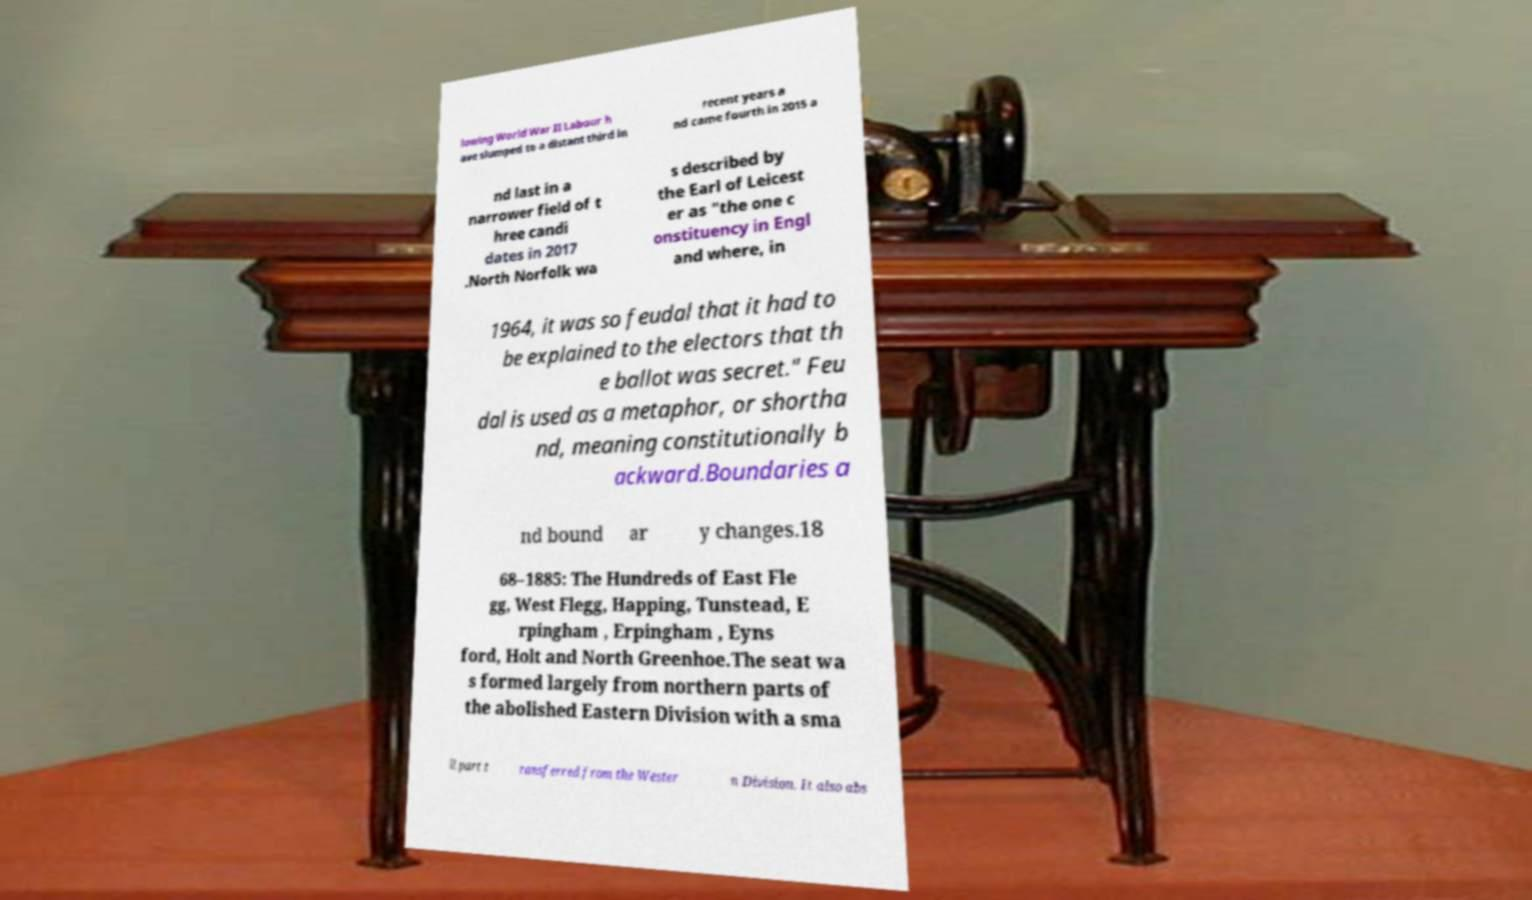Can you accurately transcribe the text from the provided image for me? lowing World War II Labour h ave slumped to a distant third in recent years a nd came fourth in 2015 a nd last in a narrower field of t hree candi dates in 2017 .North Norfolk wa s described by the Earl of Leicest er as "the one c onstituency in Engl and where, in 1964, it was so feudal that it had to be explained to the electors that th e ballot was secret." Feu dal is used as a metaphor, or shortha nd, meaning constitutionally b ackward.Boundaries a nd bound ar y changes.18 68–1885: The Hundreds of East Fle gg, West Flegg, Happing, Tunstead, E rpingham , Erpingham , Eyns ford, Holt and North Greenhoe.The seat wa s formed largely from northern parts of the abolished Eastern Division with a sma ll part t ransferred from the Wester n Division. It also abs 